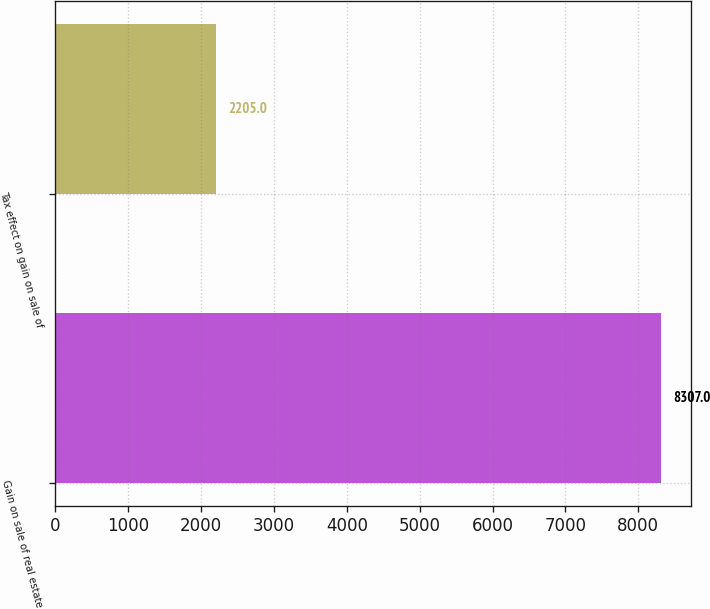Convert chart. <chart><loc_0><loc_0><loc_500><loc_500><bar_chart><fcel>Gain on sale of real estate<fcel>Tax effect on gain on sale of<nl><fcel>8307<fcel>2205<nl></chart> 